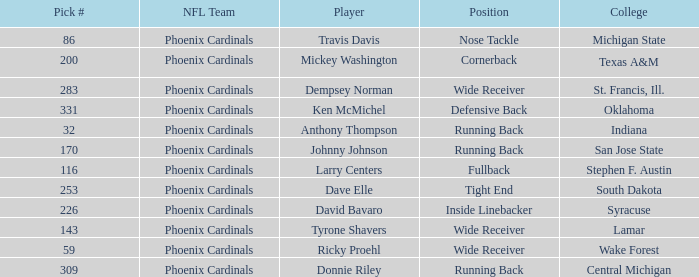Which NFL team has a pick# less than 200 for Travis Davis? Phoenix Cardinals. 